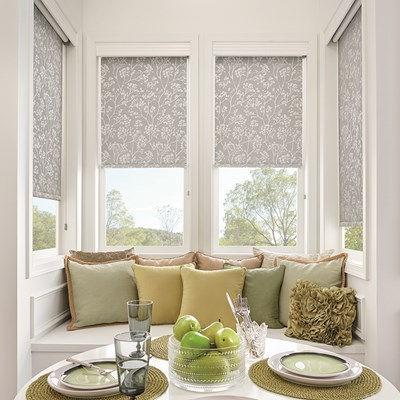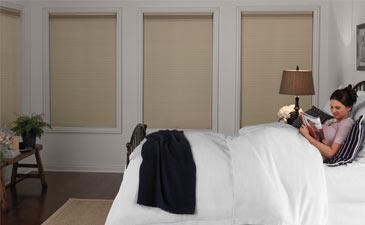The first image is the image on the left, the second image is the image on the right. Considering the images on both sides, is "At least one of the images is focused on a single window, with a black shade drawn most of the way down." valid? Answer yes or no. No. 